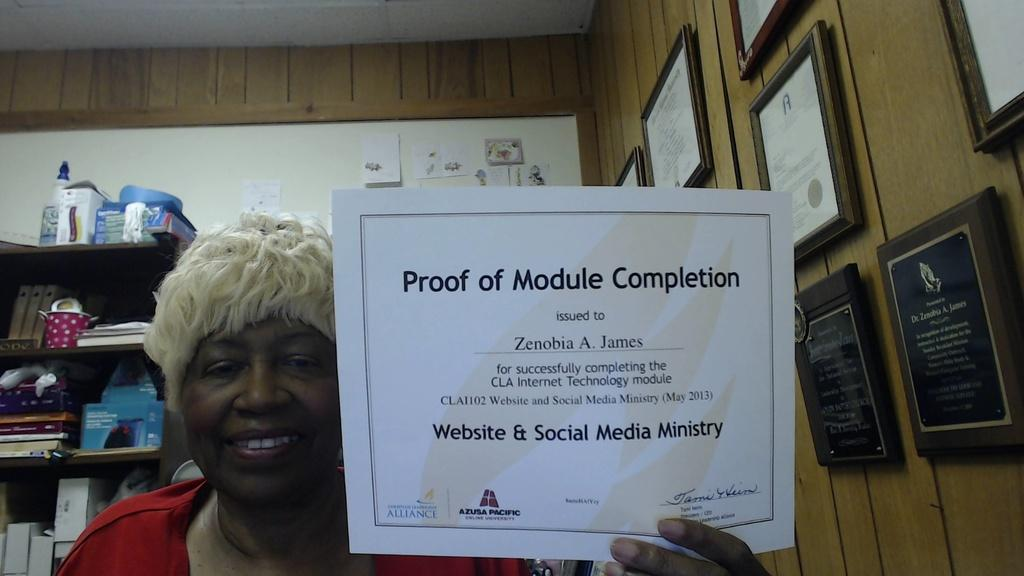<image>
Provide a brief description of the given image. Zenobia A. James holds her certificate for Proof of Module Completion. 